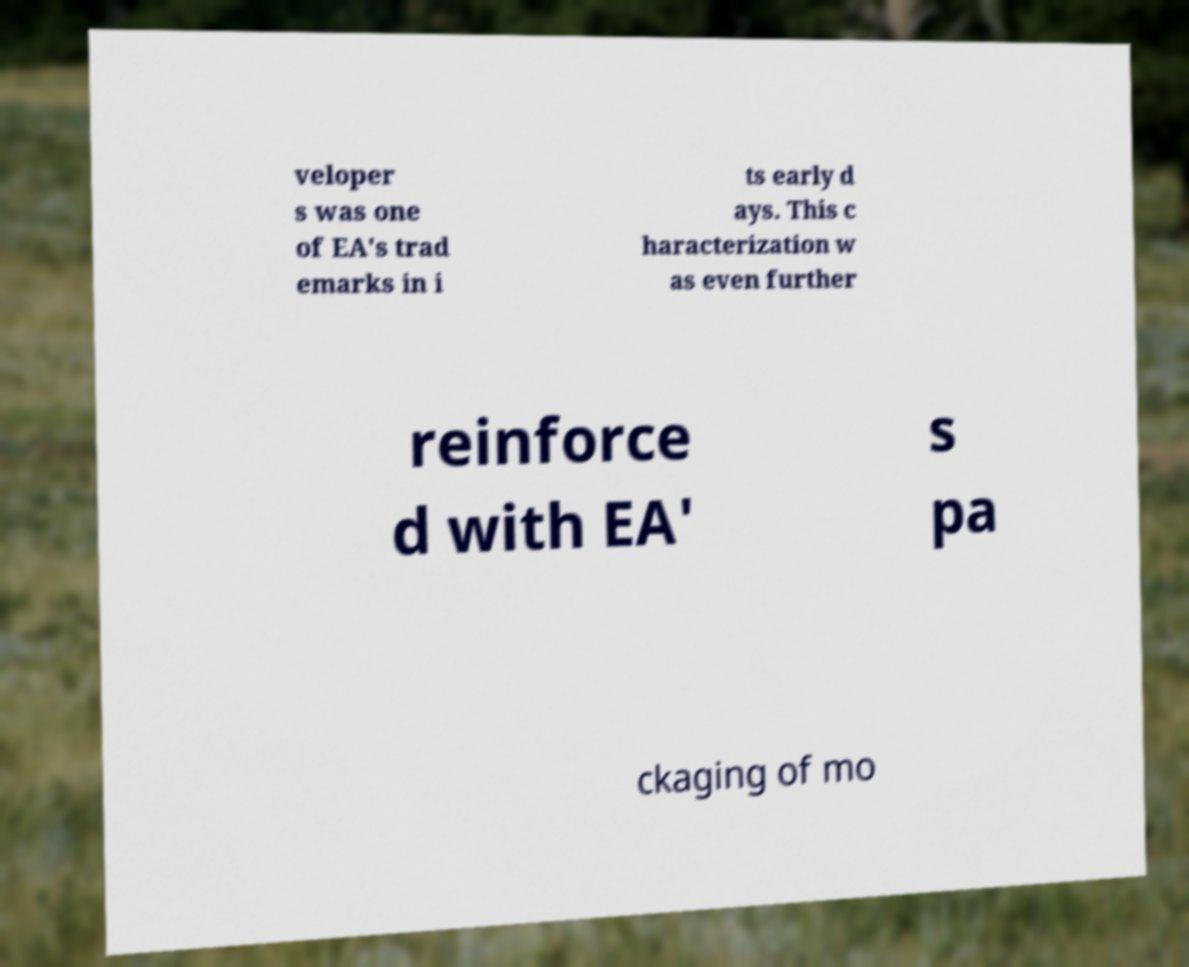I need the written content from this picture converted into text. Can you do that? veloper s was one of EA's trad emarks in i ts early d ays. This c haracterization w as even further reinforce d with EA' s pa ckaging of mo 